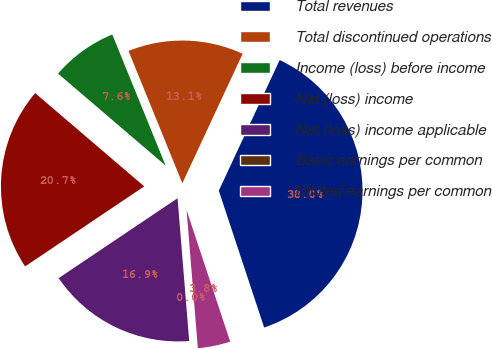<chart> <loc_0><loc_0><loc_500><loc_500><pie_chart><fcel>Total revenues<fcel>Total discontinued operations<fcel>Income (loss) before income<fcel>Net (loss) income<fcel>Net (loss) income applicable<fcel>Basic earnings per common<fcel>Diluted earnings per common<nl><fcel>37.97%<fcel>13.09%<fcel>7.59%<fcel>20.68%<fcel>16.88%<fcel>0.0%<fcel>3.8%<nl></chart> 